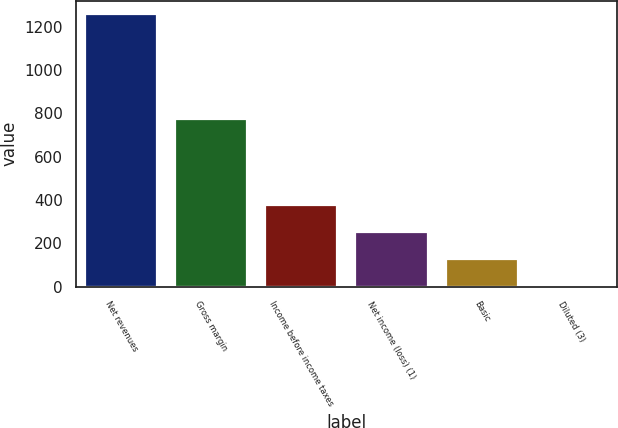Convert chart to OTSL. <chart><loc_0><loc_0><loc_500><loc_500><bar_chart><fcel>Net revenues<fcel>Gross margin<fcel>Income before income taxes<fcel>Net income (loss) (1)<fcel>Basic<fcel>Diluted (3)<nl><fcel>1257.8<fcel>772.4<fcel>377.65<fcel>251.91<fcel>126.17<fcel>0.43<nl></chart> 